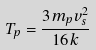<formula> <loc_0><loc_0><loc_500><loc_500>T _ { p } = \frac { 3 m _ { p } v _ { s } ^ { 2 } } { 1 6 k }</formula> 